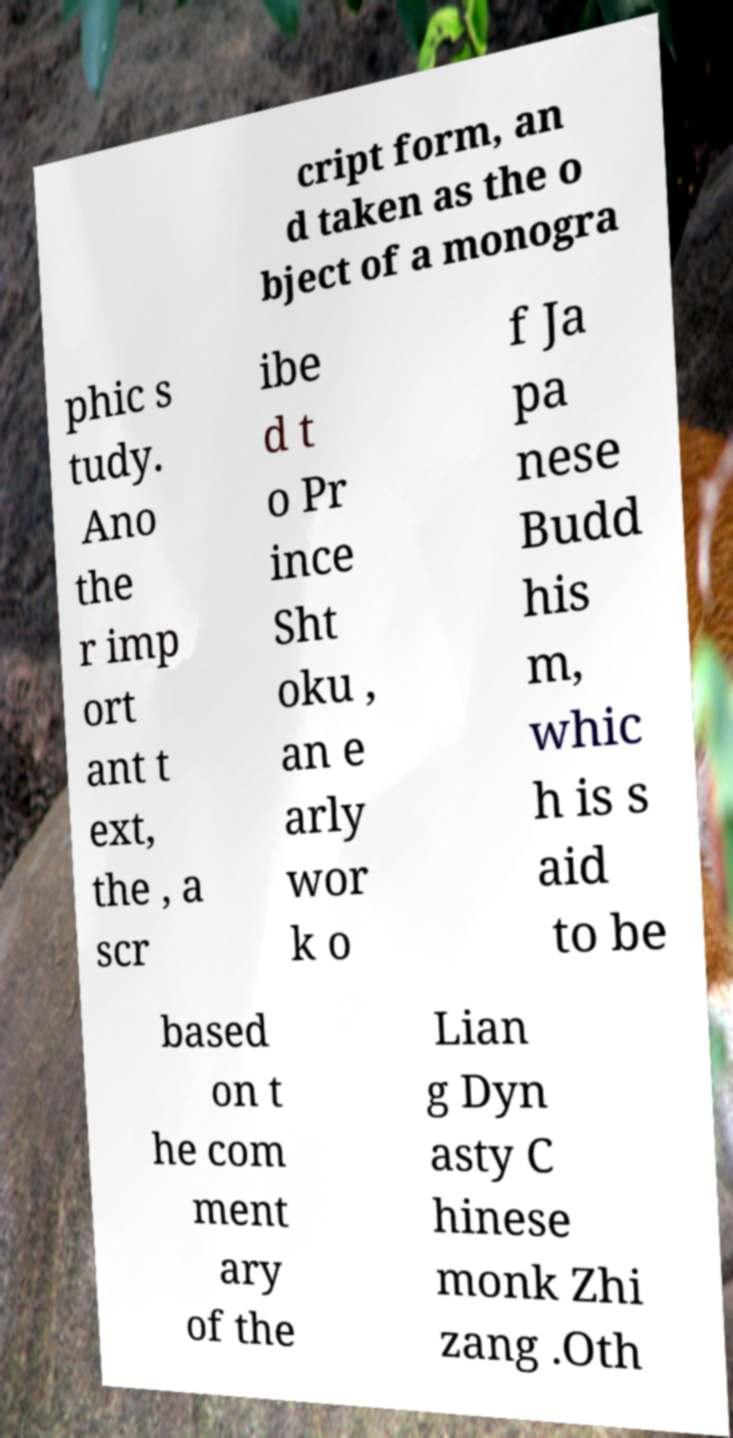What messages or text are displayed in this image? I need them in a readable, typed format. cript form, an d taken as the o bject of a monogra phic s tudy. Ano the r imp ort ant t ext, the , a scr ibe d t o Pr ince Sht oku , an e arly wor k o f Ja pa nese Budd his m, whic h is s aid to be based on t he com ment ary of the Lian g Dyn asty C hinese monk Zhi zang .Oth 